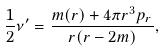<formula> <loc_0><loc_0><loc_500><loc_500>\frac { 1 } { 2 } { \nu } ^ { \prime } = \frac { m ( r ) + 4 \pi r ^ { 3 } p _ { r } } { r ( r - 2 m ) } ,</formula> 